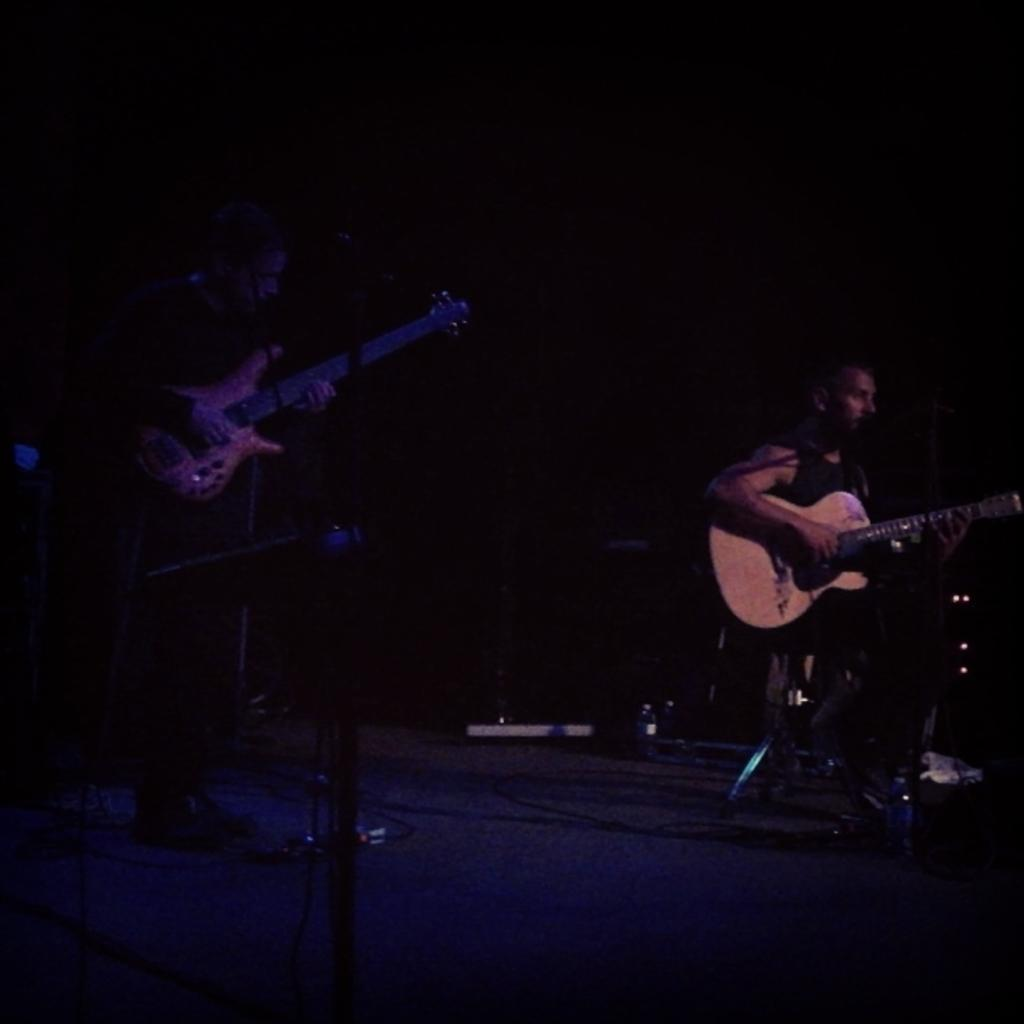How many people are in the image? There are two men in the image. What are the men doing in the image? The men are playing guitar and singing. What tool are they using to amplify their voices? They are using a microphone. What type of event might be taking place in the image? The scene appears to be a concert. What type of texture can be seen on the birthday cake in the image? There is no birthday cake present in the image. What role does the parent play in the image? There is no parent present in the image. 